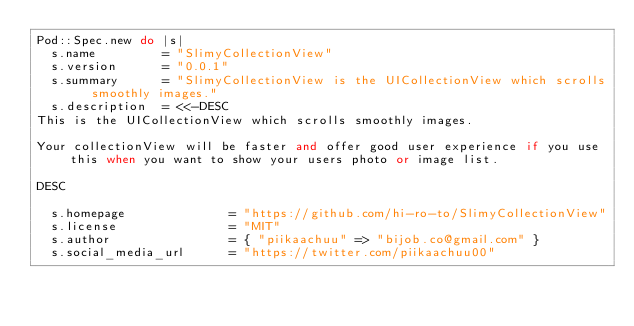<code> <loc_0><loc_0><loc_500><loc_500><_Ruby_>Pod::Spec.new do |s|
  s.name         = "SlimyCollectionView"
  s.version      = "0.0.1"
  s.summary      = "SlimyCollectionView is the UICollectionView which scrolls smoothly images."
  s.description  = <<-DESC
This is the UICollectionView which scrolls smoothly images.

Your collectionView will be faster and offer good user experience if you use this when you want to show your users photo or image list.

DESC

  s.homepage              = "https://github.com/hi-ro-to/SlimyCollectionView"
  s.license               = "MIT"
  s.author                = { "piikaachuu" => "bijob.co@gmail.com" }
  s.social_media_url      = "https://twitter.com/piikaachuu00"</code> 